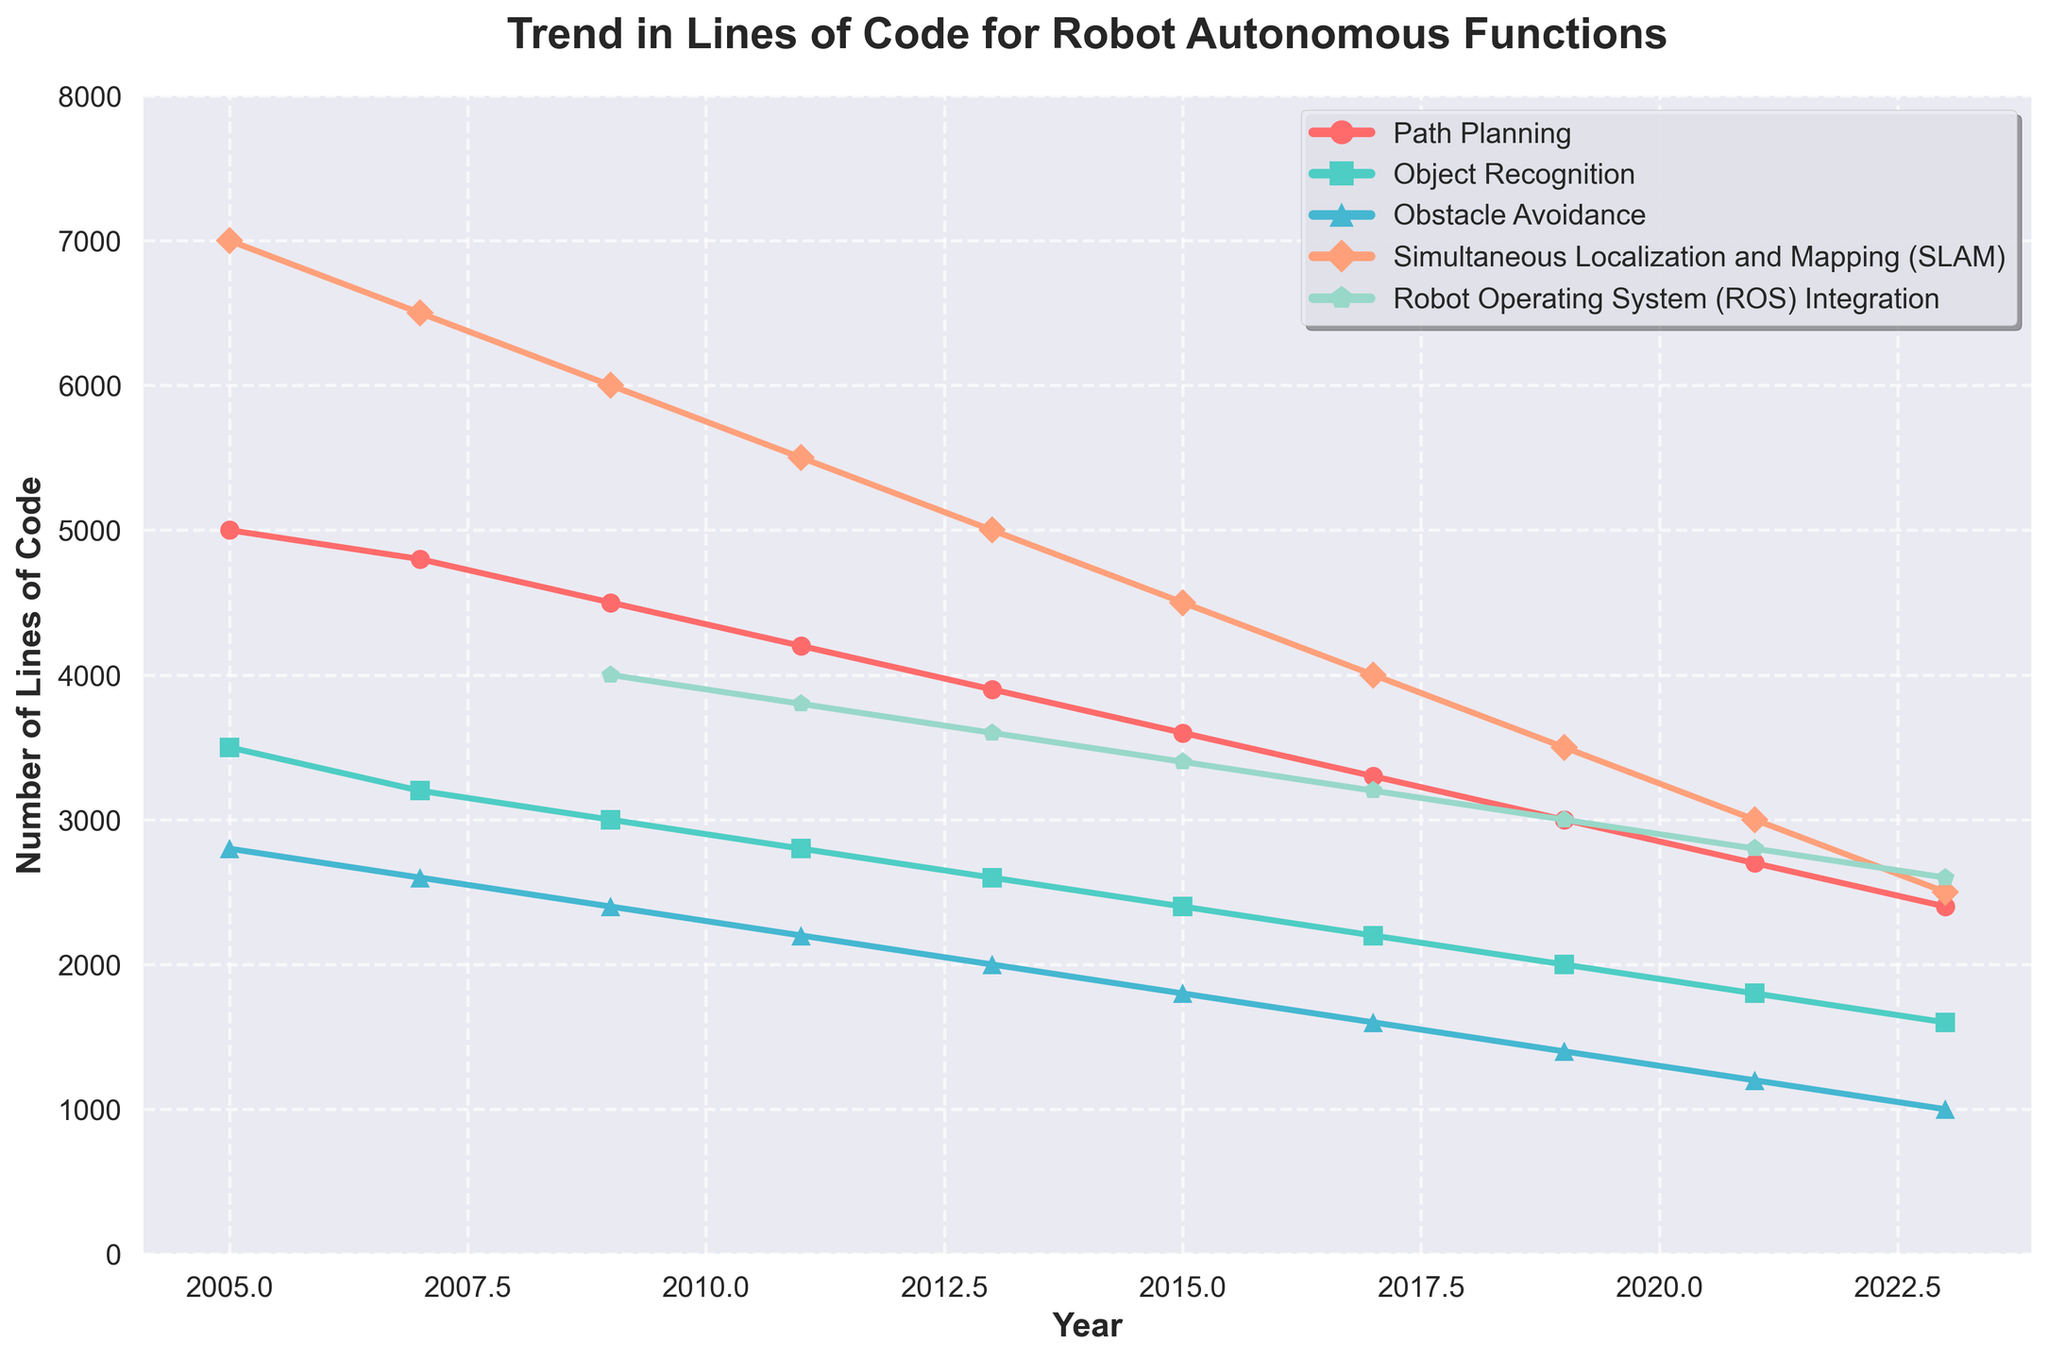what is the overall trend in the lines of code for Path Planning from 2005 to 2023? Observe the line for Path Planning in the chart, which is marked with markers and color red. Starting in 2005, the number of lines of code decreases from 5000 to 2400 in 2023, indicating a general downward trend.
Answer: Downward trend Which autonomous function had the least number of lines of code in 2023? Look at the data points for 2023 for the colors representing each autonomous function. The function with the lowest value in 2023 is Obstacle Avoidance with 1000 lines of code.
Answer: Obstacle Avoidance How did the number of lines of code for Simultaneous Localization and Mapping (SLAM) change from 2011 to 2017? Check the SLAM line marked with a specific color and shape of markers. The number of lines decreased from 5500 in 2011 to 4000 in 2017. Calculate the difference: 5500 - 4000 = 1500.
Answer: Decreased by 1500 lines of code What is the difference in the number of lines of code between Object Recognition and ROS Integration in 2009? Find the data points for 2009 for Object Recognition and ROS Integration. Object Recognition has 3000 lines, and ROS Integration has 4000 lines. The difference is 4000 - 3000 = 1000.
Answer: 1000 lines of code Which function experienced the smallest change in the number of lines of code from 2017 to 2023? Review the changes in the number of lines of code for all functions between 2017 and 2023. Calculate the differences: Path Planning (3300 to 2400 = 900), Object Recognition (2200 to 1600 = 600), Obstacle Avoidance (1600 to 1000 = 600), SLAM (4000 to 2500 = 1500), ROS Integration (3200 to 2600 = 600). The smallest change is for Object Recognition, Obstacle Avoidance, and ROS Integration (each 600).
Answer: Object Recognition, Obstacle Avoidance, ROS Integration Was there any year when the number of lines of code for Object Recognition and Path Planning were equal? Compare the data points year by year for Object Recognition and Path Planning. In all years, the number of lines of code for Object Recognition is less than Path Planning. Hence, they were never equal.
Answer: No What is the average number of lines of code for Path Planning over the years provided in the data? Sum all the values for Path Planning from 2005 to 2023: (5000 + 4800 + 4500 + 4200 + 3900 + 3600 + 3300 + 3000 + 2700 + 2400) = 36400. Divide by the number of years (10): 36400 / 10 = 3640.
Answer: 3640 lines of code How does the number of lines of code for ROS Integration in 2021 compare to that of SLAM in the same year? Look at the data points for 2021 for both ROS Integration (2800) and SLAM (3000). SLAM has more lines of code than ROS Integration.
Answer: SLAM has more lines of code Which function saw a continuous decrease in the number of lines of code across all documented years? Analyze each function's trend lines. Path Planning, Object Recognition, Obstacle Avoidance, and SLAM each show a continuous decrease across all years.
Answer: Path Planning, Object Recognition, Obstacle Avoidance, SLAM 